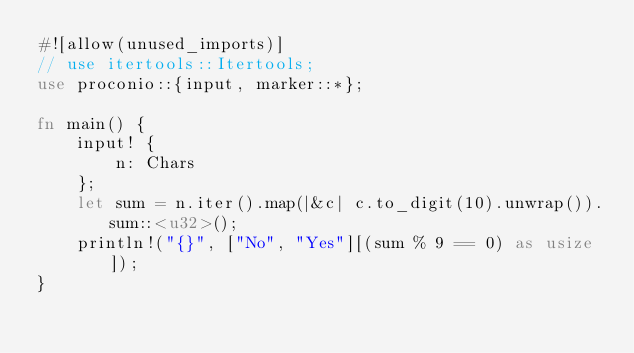<code> <loc_0><loc_0><loc_500><loc_500><_Rust_>#![allow(unused_imports)]
// use itertools::Itertools;
use proconio::{input, marker::*};

fn main() {
    input! {
        n: Chars
    };
    let sum = n.iter().map(|&c| c.to_digit(10).unwrap()).sum::<u32>();
    println!("{}", ["No", "Yes"][(sum % 9 == 0) as usize]);
}
</code> 